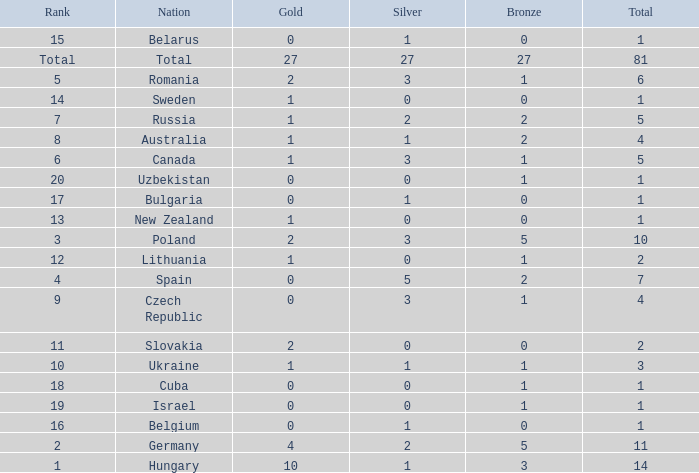How much Bronze has a Gold larger than 1, and a Silver smaller than 3, and a Nation of germany, and a Total larger than 11? 0.0. 